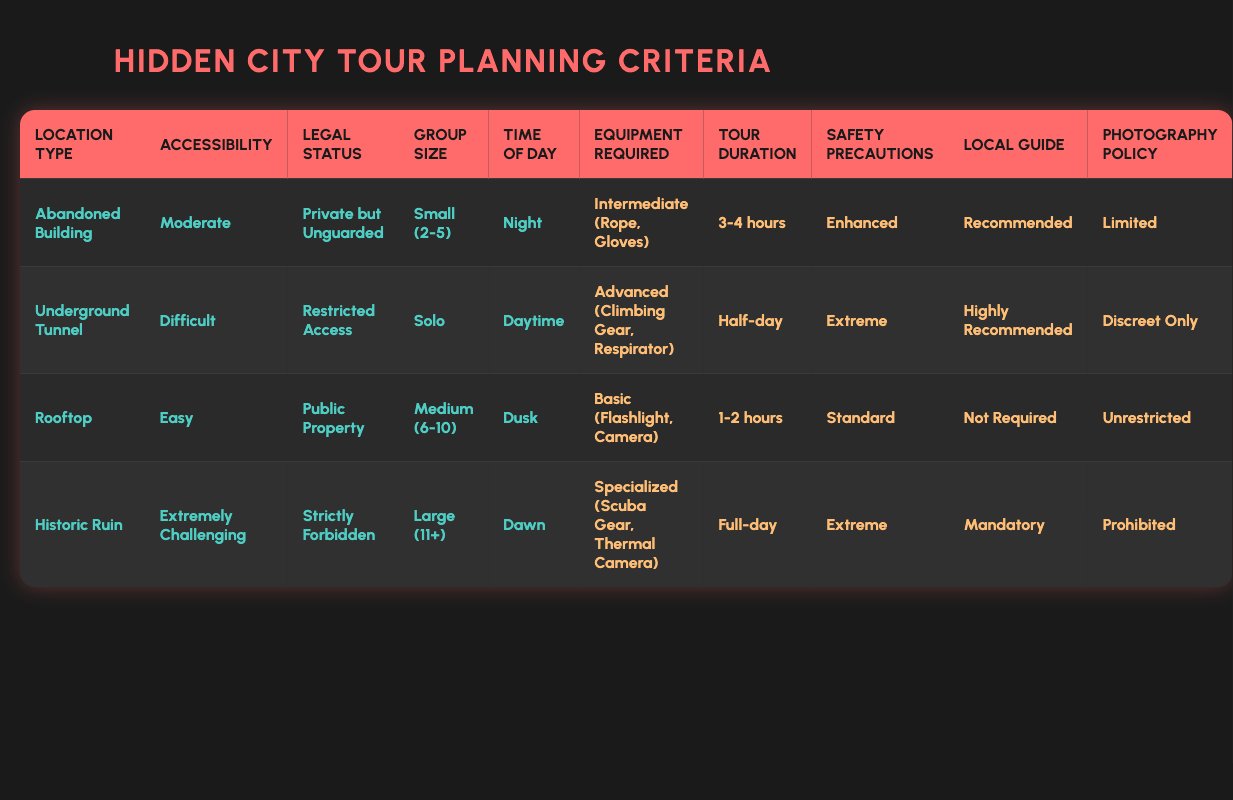What is the required equipment for exploring a rooftop? The table indicates that for a rooftop with easy accessibility and public property status, the required equipment is basic, which includes a flashlight and a camera.
Answer: Basic (Flashlight, Camera) How long is the tour duration for visiting an abandoned building at night? According to the table, when exploring an abandoned building with moderate accessibility, private but unguarded legal status, small group size, and during the night, the tour duration is 3-4 hours.
Answer: 3-4 hours Is it true that a local guide is mandatory for exploring a historic ruin? The table shows that for a historic ruin with extremely challenging accessibility, strictly forbidden legal status, a large group size, and at dawn, having a local guide is marked as mandatory. Thus, the statement is true.
Answer: Yes What equipment is needed for an underground tunnel that is difficult to access during the daytime? In the case of an underground tunnel with difficult accessibility, restricted access legal status, and solo exploration during the daytime, the required equipment is categorized as advanced, which includes climbing gear and a respirator.
Answer: Advanced (Climbing Gear, Respirator) What is the total number of safety precautions recommended for exploring the roofs and the abandoned building at night? The table indicates that exploring a rooftop has standard safety precautions, while an abandoned building requires enhanced safety precautions. Hence, the total would be the sum: standard + enhanced, which means considering 'standard' as 1 and 'enhanced' as 2, the total number is 3.
Answer: 3 What group size is allowed for the underground tunnel exploration? The table clearly indicates that the underground tunnel exploration is only suitable for solo adventurers, as noted in the conditions for that location.
Answer: Solo For what circumstances photography is prohibited? Photography is prohibited in the case of exploring a historic ruin characterized by extremely challenging accessibility, strictly forbidden legal status, large group size, and conducted at dawn. Thus, the circumstances leading to prohibition are those stated.
Answer: Historic Ruin What is the average tour duration between the abandoned building and the rooftop? The tour duration for the abandoned building is 3-4 hours, and for the rooftop, it is 1-2 hours. To find the average, calculate the middle value of each range: (3.5 hours + 1.5 hours) / 2 = 2.5 hours, which gives you the final average of 2.5 hours.
Answer: 2.5 hours If I want to explore a rooftop at dusk, do I need to worry about safety precautions? The table states that when exploring a rooftop at dusk, safety precautions are standard, which means while they exist, they are not heightened compared to other locations. Thus, there is minimal concern as it indicates a relative safety.
Answer: No 